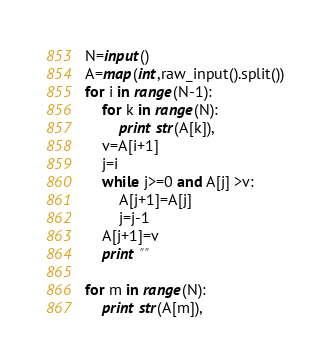<code> <loc_0><loc_0><loc_500><loc_500><_Python_>N=input()
A=map(int,raw_input().split())
for i in range(N-1):
	for k in range(N):
		print str(A[k]),
	v=A[i+1]
	j=i
	while j>=0 and A[j] >v:
		A[j+1]=A[j]
		j=j-1
	A[j+1]=v
	print ""

for m in range(N):
	print str(A[m]),</code> 